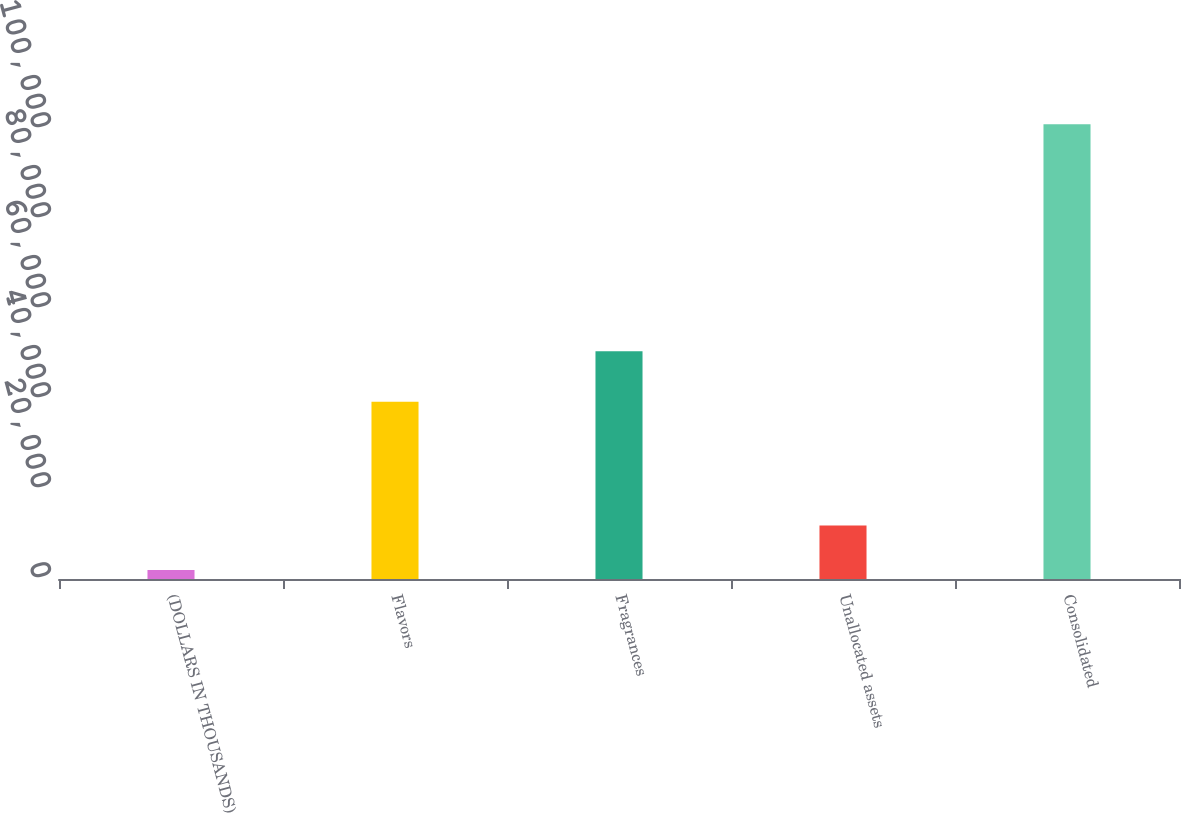Convert chart. <chart><loc_0><loc_0><loc_500><loc_500><bar_chart><fcel>(DOLLARS IN THOUSANDS)<fcel>Flavors<fcel>Fragrances<fcel>Unallocated assets<fcel>Consolidated<nl><fcel>2015<fcel>39416<fcel>50597<fcel>11916.5<fcel>101030<nl></chart> 